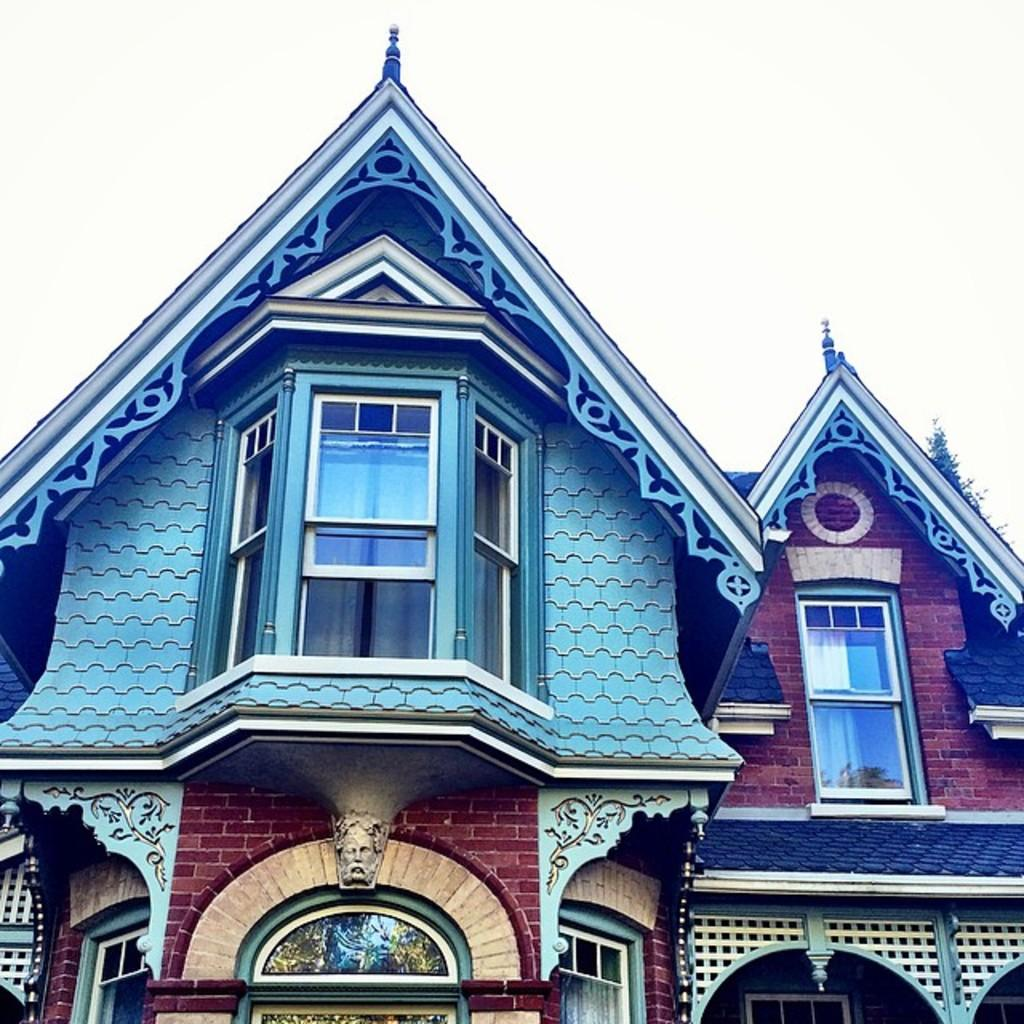What type of structure is present in the image? There is a building in the image. What colors are used on the building? The building has brown and blue colors. What feature can be seen on the building? There are glass windows on the building. What is visible in the background of the image? The sky is visible in the image. Can you see any tents or waste in the image? No, there are no tents or waste visible in the image. Are there any jellyfish swimming in the sky in the image? No, there are no jellyfish present in the image, and the sky is not depicted as a body of water where jellyfish could swim. 